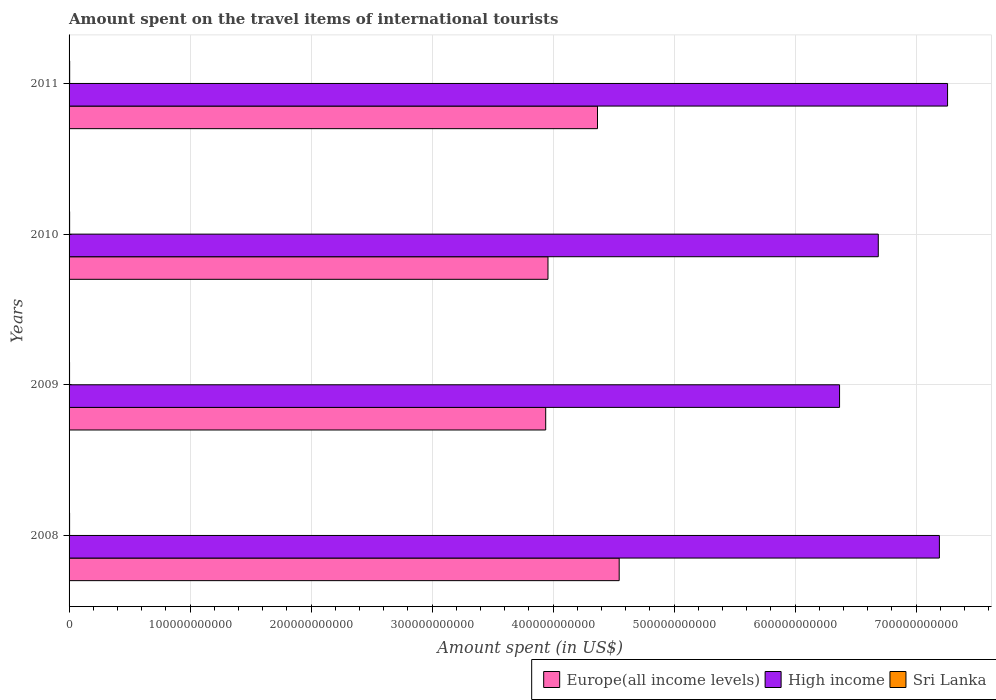How many different coloured bars are there?
Offer a terse response. 3. Are the number of bars per tick equal to the number of legend labels?
Your response must be concise. Yes. How many bars are there on the 2nd tick from the bottom?
Offer a terse response. 3. What is the label of the 1st group of bars from the top?
Your answer should be very brief. 2011. In how many cases, is the number of bars for a given year not equal to the number of legend labels?
Offer a very short reply. 0. What is the amount spent on the travel items of international tourists in Sri Lanka in 2009?
Your answer should be very brief. 4.11e+08. Across all years, what is the maximum amount spent on the travel items of international tourists in High income?
Make the answer very short. 7.26e+11. Across all years, what is the minimum amount spent on the travel items of international tourists in Sri Lanka?
Offer a very short reply. 4.11e+08. What is the total amount spent on the travel items of international tourists in Europe(all income levels) in the graph?
Offer a very short reply. 1.68e+12. What is the difference between the amount spent on the travel items of international tourists in Europe(all income levels) in 2009 and that in 2010?
Offer a very short reply. -1.87e+09. What is the difference between the amount spent on the travel items of international tourists in Sri Lanka in 2009 and the amount spent on the travel items of international tourists in Europe(all income levels) in 2011?
Keep it short and to the point. -4.36e+11. What is the average amount spent on the travel items of international tourists in High income per year?
Your response must be concise. 6.88e+11. In the year 2008, what is the difference between the amount spent on the travel items of international tourists in High income and amount spent on the travel items of international tourists in Sri Lanka?
Offer a terse response. 7.19e+11. In how many years, is the amount spent on the travel items of international tourists in Sri Lanka greater than 400000000000 US$?
Provide a succinct answer. 0. What is the ratio of the amount spent on the travel items of international tourists in High income in 2009 to that in 2011?
Offer a terse response. 0.88. Is the difference between the amount spent on the travel items of international tourists in High income in 2009 and 2011 greater than the difference between the amount spent on the travel items of international tourists in Sri Lanka in 2009 and 2011?
Your response must be concise. No. What is the difference between the highest and the second highest amount spent on the travel items of international tourists in Europe(all income levels)?
Offer a terse response. 1.79e+1. What is the difference between the highest and the lowest amount spent on the travel items of international tourists in High income?
Give a very brief answer. 8.93e+1. What does the 1st bar from the top in 2008 represents?
Make the answer very short. Sri Lanka. What does the 3rd bar from the bottom in 2008 represents?
Provide a short and direct response. Sri Lanka. Is it the case that in every year, the sum of the amount spent on the travel items of international tourists in Europe(all income levels) and amount spent on the travel items of international tourists in Sri Lanka is greater than the amount spent on the travel items of international tourists in High income?
Offer a very short reply. No. How many bars are there?
Your answer should be compact. 12. Are all the bars in the graph horizontal?
Make the answer very short. Yes. How many years are there in the graph?
Offer a very short reply. 4. What is the difference between two consecutive major ticks on the X-axis?
Your response must be concise. 1.00e+11. Does the graph contain any zero values?
Provide a succinct answer. No. Does the graph contain grids?
Your answer should be compact. Yes. Where does the legend appear in the graph?
Your response must be concise. Bottom right. What is the title of the graph?
Offer a very short reply. Amount spent on the travel items of international tourists. What is the label or title of the X-axis?
Provide a short and direct response. Amount spent (in US$). What is the label or title of the Y-axis?
Offer a terse response. Years. What is the Amount spent (in US$) of Europe(all income levels) in 2008?
Your answer should be compact. 4.55e+11. What is the Amount spent (in US$) of High income in 2008?
Offer a very short reply. 7.19e+11. What is the Amount spent (in US$) of Sri Lanka in 2008?
Give a very brief answer. 4.28e+08. What is the Amount spent (in US$) of Europe(all income levels) in 2009?
Offer a very short reply. 3.94e+11. What is the Amount spent (in US$) in High income in 2009?
Offer a very short reply. 6.37e+11. What is the Amount spent (in US$) in Sri Lanka in 2009?
Provide a short and direct response. 4.11e+08. What is the Amount spent (in US$) in Europe(all income levels) in 2010?
Provide a short and direct response. 3.96e+11. What is the Amount spent (in US$) of High income in 2010?
Provide a succinct answer. 6.69e+11. What is the Amount spent (in US$) in Sri Lanka in 2010?
Your response must be concise. 4.53e+08. What is the Amount spent (in US$) in Europe(all income levels) in 2011?
Your answer should be compact. 4.37e+11. What is the Amount spent (in US$) of High income in 2011?
Offer a terse response. 7.26e+11. What is the Amount spent (in US$) in Sri Lanka in 2011?
Give a very brief answer. 5.01e+08. Across all years, what is the maximum Amount spent (in US$) of Europe(all income levels)?
Keep it short and to the point. 4.55e+11. Across all years, what is the maximum Amount spent (in US$) in High income?
Provide a short and direct response. 7.26e+11. Across all years, what is the maximum Amount spent (in US$) in Sri Lanka?
Ensure brevity in your answer.  5.01e+08. Across all years, what is the minimum Amount spent (in US$) of Europe(all income levels)?
Keep it short and to the point. 3.94e+11. Across all years, what is the minimum Amount spent (in US$) in High income?
Offer a terse response. 6.37e+11. Across all years, what is the minimum Amount spent (in US$) in Sri Lanka?
Ensure brevity in your answer.  4.11e+08. What is the total Amount spent (in US$) in Europe(all income levels) in the graph?
Offer a very short reply. 1.68e+12. What is the total Amount spent (in US$) in High income in the graph?
Keep it short and to the point. 2.75e+12. What is the total Amount spent (in US$) in Sri Lanka in the graph?
Keep it short and to the point. 1.79e+09. What is the difference between the Amount spent (in US$) in Europe(all income levels) in 2008 and that in 2009?
Ensure brevity in your answer.  6.07e+1. What is the difference between the Amount spent (in US$) in High income in 2008 and that in 2009?
Your answer should be compact. 8.25e+1. What is the difference between the Amount spent (in US$) in Sri Lanka in 2008 and that in 2009?
Keep it short and to the point. 1.70e+07. What is the difference between the Amount spent (in US$) in Europe(all income levels) in 2008 and that in 2010?
Ensure brevity in your answer.  5.88e+1. What is the difference between the Amount spent (in US$) of High income in 2008 and that in 2010?
Your answer should be compact. 5.05e+1. What is the difference between the Amount spent (in US$) of Sri Lanka in 2008 and that in 2010?
Give a very brief answer. -2.50e+07. What is the difference between the Amount spent (in US$) in Europe(all income levels) in 2008 and that in 2011?
Provide a short and direct response. 1.79e+1. What is the difference between the Amount spent (in US$) in High income in 2008 and that in 2011?
Keep it short and to the point. -6.76e+09. What is the difference between the Amount spent (in US$) in Sri Lanka in 2008 and that in 2011?
Your answer should be compact. -7.30e+07. What is the difference between the Amount spent (in US$) of Europe(all income levels) in 2009 and that in 2010?
Make the answer very short. -1.87e+09. What is the difference between the Amount spent (in US$) in High income in 2009 and that in 2010?
Your answer should be compact. -3.20e+1. What is the difference between the Amount spent (in US$) in Sri Lanka in 2009 and that in 2010?
Ensure brevity in your answer.  -4.20e+07. What is the difference between the Amount spent (in US$) of Europe(all income levels) in 2009 and that in 2011?
Give a very brief answer. -4.28e+1. What is the difference between the Amount spent (in US$) in High income in 2009 and that in 2011?
Offer a terse response. -8.93e+1. What is the difference between the Amount spent (in US$) of Sri Lanka in 2009 and that in 2011?
Ensure brevity in your answer.  -9.00e+07. What is the difference between the Amount spent (in US$) in Europe(all income levels) in 2010 and that in 2011?
Your answer should be compact. -4.09e+1. What is the difference between the Amount spent (in US$) in High income in 2010 and that in 2011?
Keep it short and to the point. -5.73e+1. What is the difference between the Amount spent (in US$) in Sri Lanka in 2010 and that in 2011?
Make the answer very short. -4.80e+07. What is the difference between the Amount spent (in US$) in Europe(all income levels) in 2008 and the Amount spent (in US$) in High income in 2009?
Ensure brevity in your answer.  -1.82e+11. What is the difference between the Amount spent (in US$) of Europe(all income levels) in 2008 and the Amount spent (in US$) of Sri Lanka in 2009?
Offer a terse response. 4.54e+11. What is the difference between the Amount spent (in US$) of High income in 2008 and the Amount spent (in US$) of Sri Lanka in 2009?
Make the answer very short. 7.19e+11. What is the difference between the Amount spent (in US$) in Europe(all income levels) in 2008 and the Amount spent (in US$) in High income in 2010?
Provide a succinct answer. -2.14e+11. What is the difference between the Amount spent (in US$) of Europe(all income levels) in 2008 and the Amount spent (in US$) of Sri Lanka in 2010?
Your response must be concise. 4.54e+11. What is the difference between the Amount spent (in US$) in High income in 2008 and the Amount spent (in US$) in Sri Lanka in 2010?
Ensure brevity in your answer.  7.19e+11. What is the difference between the Amount spent (in US$) in Europe(all income levels) in 2008 and the Amount spent (in US$) in High income in 2011?
Provide a succinct answer. -2.71e+11. What is the difference between the Amount spent (in US$) in Europe(all income levels) in 2008 and the Amount spent (in US$) in Sri Lanka in 2011?
Your answer should be compact. 4.54e+11. What is the difference between the Amount spent (in US$) of High income in 2008 and the Amount spent (in US$) of Sri Lanka in 2011?
Your response must be concise. 7.19e+11. What is the difference between the Amount spent (in US$) in Europe(all income levels) in 2009 and the Amount spent (in US$) in High income in 2010?
Provide a short and direct response. -2.75e+11. What is the difference between the Amount spent (in US$) of Europe(all income levels) in 2009 and the Amount spent (in US$) of Sri Lanka in 2010?
Your answer should be very brief. 3.93e+11. What is the difference between the Amount spent (in US$) of High income in 2009 and the Amount spent (in US$) of Sri Lanka in 2010?
Your response must be concise. 6.36e+11. What is the difference between the Amount spent (in US$) of Europe(all income levels) in 2009 and the Amount spent (in US$) of High income in 2011?
Make the answer very short. -3.32e+11. What is the difference between the Amount spent (in US$) of Europe(all income levels) in 2009 and the Amount spent (in US$) of Sri Lanka in 2011?
Give a very brief answer. 3.93e+11. What is the difference between the Amount spent (in US$) of High income in 2009 and the Amount spent (in US$) of Sri Lanka in 2011?
Offer a very short reply. 6.36e+11. What is the difference between the Amount spent (in US$) in Europe(all income levels) in 2010 and the Amount spent (in US$) in High income in 2011?
Provide a short and direct response. -3.30e+11. What is the difference between the Amount spent (in US$) of Europe(all income levels) in 2010 and the Amount spent (in US$) of Sri Lanka in 2011?
Provide a short and direct response. 3.95e+11. What is the difference between the Amount spent (in US$) in High income in 2010 and the Amount spent (in US$) in Sri Lanka in 2011?
Your answer should be very brief. 6.68e+11. What is the average Amount spent (in US$) in Europe(all income levels) per year?
Your answer should be compact. 4.20e+11. What is the average Amount spent (in US$) in High income per year?
Ensure brevity in your answer.  6.88e+11. What is the average Amount spent (in US$) of Sri Lanka per year?
Your answer should be very brief. 4.48e+08. In the year 2008, what is the difference between the Amount spent (in US$) in Europe(all income levels) and Amount spent (in US$) in High income?
Offer a very short reply. -2.65e+11. In the year 2008, what is the difference between the Amount spent (in US$) of Europe(all income levels) and Amount spent (in US$) of Sri Lanka?
Keep it short and to the point. 4.54e+11. In the year 2008, what is the difference between the Amount spent (in US$) in High income and Amount spent (in US$) in Sri Lanka?
Your response must be concise. 7.19e+11. In the year 2009, what is the difference between the Amount spent (in US$) in Europe(all income levels) and Amount spent (in US$) in High income?
Your response must be concise. -2.43e+11. In the year 2009, what is the difference between the Amount spent (in US$) of Europe(all income levels) and Amount spent (in US$) of Sri Lanka?
Provide a short and direct response. 3.93e+11. In the year 2009, what is the difference between the Amount spent (in US$) of High income and Amount spent (in US$) of Sri Lanka?
Provide a succinct answer. 6.36e+11. In the year 2010, what is the difference between the Amount spent (in US$) of Europe(all income levels) and Amount spent (in US$) of High income?
Give a very brief answer. -2.73e+11. In the year 2010, what is the difference between the Amount spent (in US$) in Europe(all income levels) and Amount spent (in US$) in Sri Lanka?
Your answer should be compact. 3.95e+11. In the year 2010, what is the difference between the Amount spent (in US$) of High income and Amount spent (in US$) of Sri Lanka?
Keep it short and to the point. 6.68e+11. In the year 2011, what is the difference between the Amount spent (in US$) in Europe(all income levels) and Amount spent (in US$) in High income?
Offer a very short reply. -2.89e+11. In the year 2011, what is the difference between the Amount spent (in US$) of Europe(all income levels) and Amount spent (in US$) of Sri Lanka?
Your answer should be compact. 4.36e+11. In the year 2011, what is the difference between the Amount spent (in US$) of High income and Amount spent (in US$) of Sri Lanka?
Your response must be concise. 7.25e+11. What is the ratio of the Amount spent (in US$) in Europe(all income levels) in 2008 to that in 2009?
Ensure brevity in your answer.  1.15. What is the ratio of the Amount spent (in US$) of High income in 2008 to that in 2009?
Provide a short and direct response. 1.13. What is the ratio of the Amount spent (in US$) of Sri Lanka in 2008 to that in 2009?
Offer a terse response. 1.04. What is the ratio of the Amount spent (in US$) in Europe(all income levels) in 2008 to that in 2010?
Give a very brief answer. 1.15. What is the ratio of the Amount spent (in US$) of High income in 2008 to that in 2010?
Keep it short and to the point. 1.08. What is the ratio of the Amount spent (in US$) of Sri Lanka in 2008 to that in 2010?
Your answer should be very brief. 0.94. What is the ratio of the Amount spent (in US$) in Europe(all income levels) in 2008 to that in 2011?
Offer a terse response. 1.04. What is the ratio of the Amount spent (in US$) of High income in 2008 to that in 2011?
Provide a succinct answer. 0.99. What is the ratio of the Amount spent (in US$) of Sri Lanka in 2008 to that in 2011?
Your response must be concise. 0.85. What is the ratio of the Amount spent (in US$) of Europe(all income levels) in 2009 to that in 2010?
Make the answer very short. 1. What is the ratio of the Amount spent (in US$) of High income in 2009 to that in 2010?
Keep it short and to the point. 0.95. What is the ratio of the Amount spent (in US$) of Sri Lanka in 2009 to that in 2010?
Offer a terse response. 0.91. What is the ratio of the Amount spent (in US$) in Europe(all income levels) in 2009 to that in 2011?
Make the answer very short. 0.9. What is the ratio of the Amount spent (in US$) of High income in 2009 to that in 2011?
Offer a terse response. 0.88. What is the ratio of the Amount spent (in US$) of Sri Lanka in 2009 to that in 2011?
Offer a very short reply. 0.82. What is the ratio of the Amount spent (in US$) of Europe(all income levels) in 2010 to that in 2011?
Make the answer very short. 0.91. What is the ratio of the Amount spent (in US$) of High income in 2010 to that in 2011?
Your answer should be compact. 0.92. What is the ratio of the Amount spent (in US$) in Sri Lanka in 2010 to that in 2011?
Offer a very short reply. 0.9. What is the difference between the highest and the second highest Amount spent (in US$) in Europe(all income levels)?
Offer a very short reply. 1.79e+1. What is the difference between the highest and the second highest Amount spent (in US$) in High income?
Your answer should be compact. 6.76e+09. What is the difference between the highest and the second highest Amount spent (in US$) of Sri Lanka?
Your answer should be compact. 4.80e+07. What is the difference between the highest and the lowest Amount spent (in US$) of Europe(all income levels)?
Make the answer very short. 6.07e+1. What is the difference between the highest and the lowest Amount spent (in US$) in High income?
Offer a terse response. 8.93e+1. What is the difference between the highest and the lowest Amount spent (in US$) of Sri Lanka?
Provide a succinct answer. 9.00e+07. 